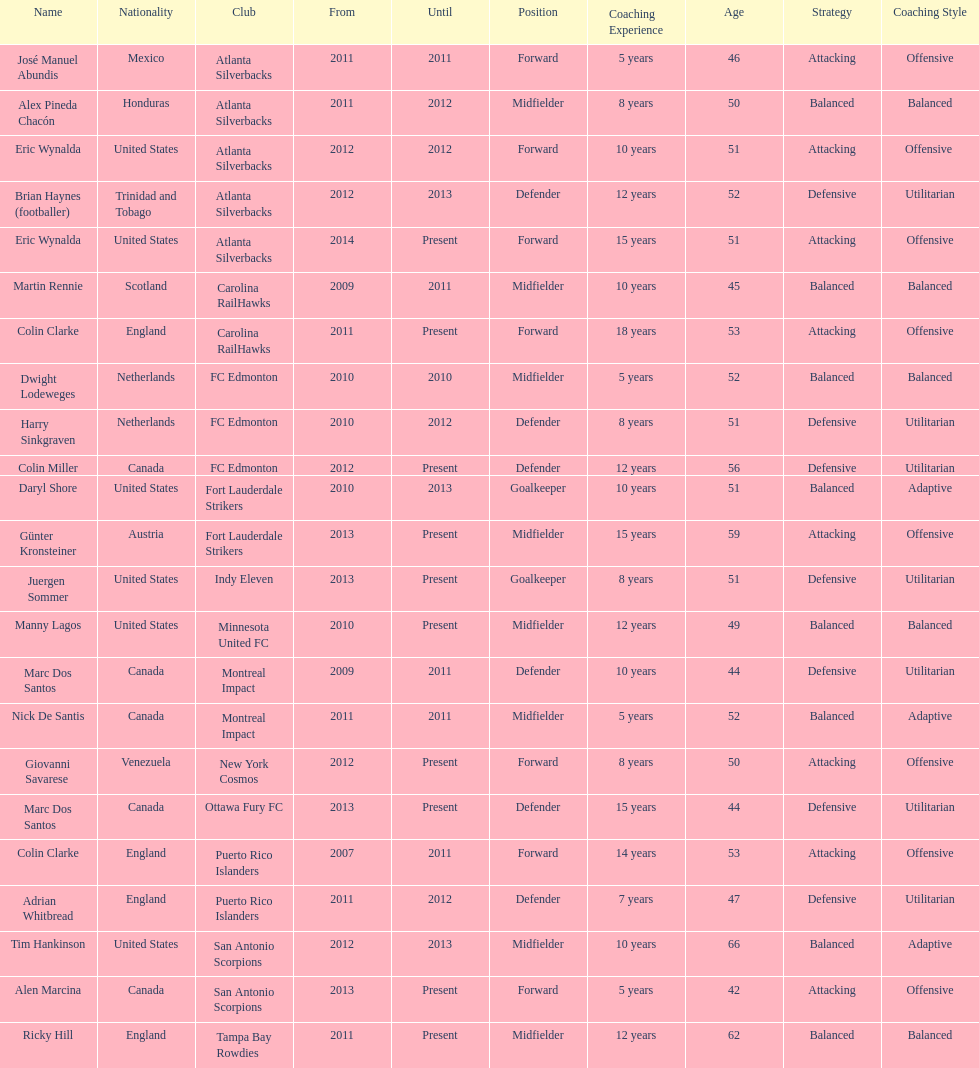How many coaches have coached from america? 6. 